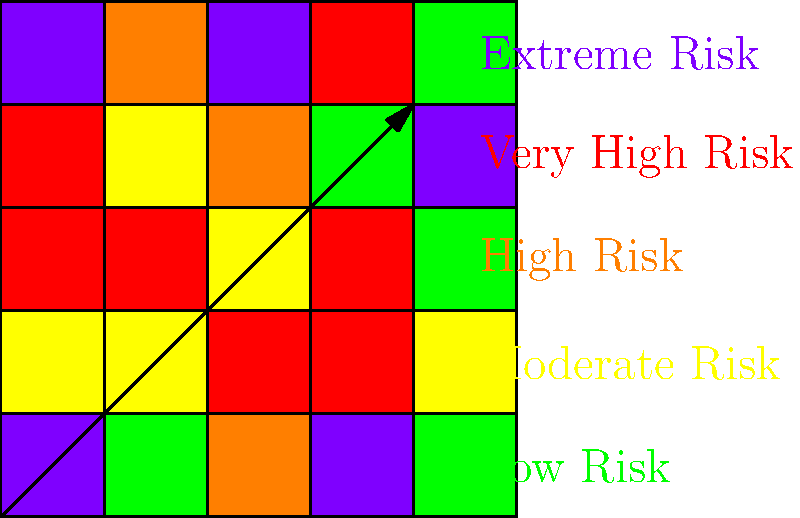Based on the color-coded health risk map provided, what percentage of the total area is classified as "Very High Risk" or "Extreme Risk"? To determine the percentage of the total area classified as "Very High Risk" or "Extreme Risk", we need to follow these steps:

1. Identify the total number of squares in the map:
   The map is a 5x5 grid, so there are 25 squares in total.

2. Count the number of squares that are colored red (Very High Risk) or purple (Extreme Risk):
   Red squares: 5
   Purple squares: 2
   Total high-risk squares: 5 + 2 = 7

3. Calculate the percentage:
   Percentage = (Number of high-risk squares / Total squares) × 100
   $$ \text{Percentage} = \frac{7}{25} \times 100 = 28\% $$

Therefore, 28% of the total area is classified as "Very High Risk" or "Extreme Risk".
Answer: 28% 